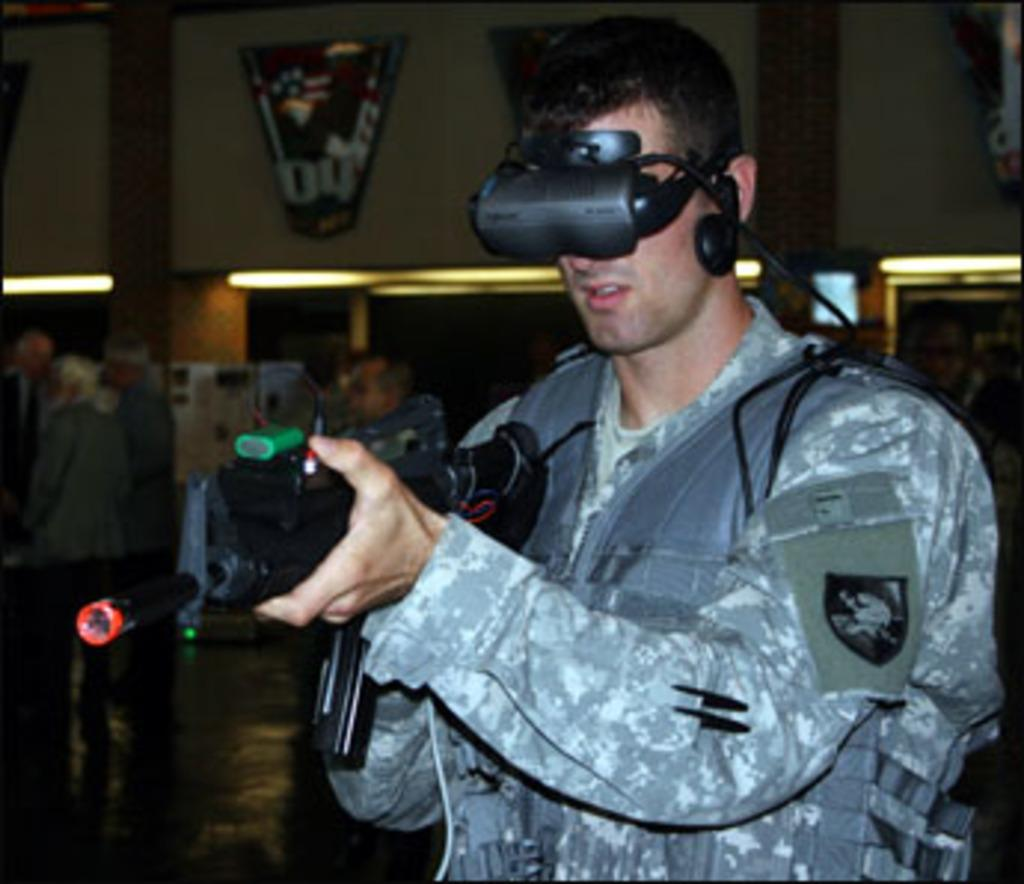What is the main subject of the image? There is a man in the image. What is the man holding in the image? The man is holding a gun. Can you describe the objects behind the man? The objects behind the man are blurred. What can be seen in the background of the image? There are lights, a wall, and people visible in the background of the image. What type of brick is the zebra holding in the image? There is no zebra or brick present in the image. What is the tin doing in the image? There is no tin present in the image. 